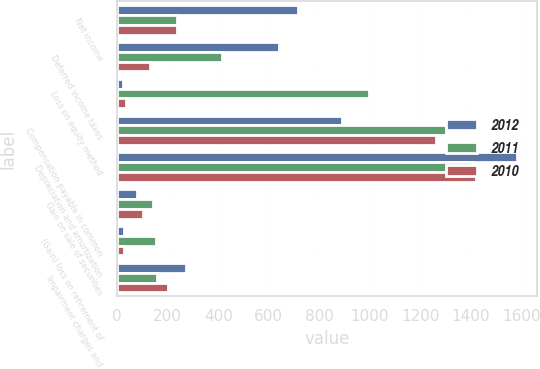<chart> <loc_0><loc_0><loc_500><loc_500><stacked_bar_chart><ecel><fcel>Net income<fcel>Deferred income taxes<fcel>Loss on equity method<fcel>Compensation payable in common<fcel>Depreciation and amortization<fcel>Gain on sale of securities<fcel>(Gain) loss on retirement of<fcel>Impairment charges and<nl><fcel>2012<fcel>716<fcel>639<fcel>23<fcel>891<fcel>1581<fcel>78<fcel>29<fcel>271<nl><fcel>2011<fcel>236<fcel>413<fcel>995<fcel>1300<fcel>1404<fcel>143<fcel>155<fcel>159<nl><fcel>2010<fcel>236<fcel>129<fcel>37<fcel>1260<fcel>1419<fcel>102<fcel>27<fcel>201<nl></chart> 